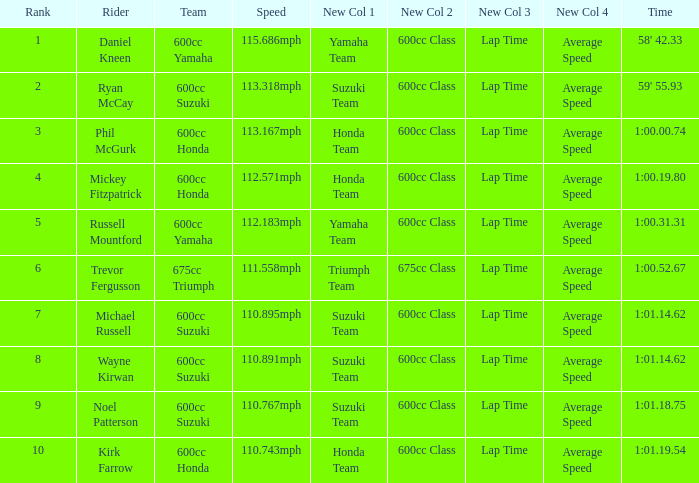How many ranks have michael russell as the rider? 7.0. 